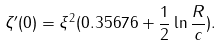Convert formula to latex. <formula><loc_0><loc_0><loc_500><loc_500>\zeta ^ { \prime } ( 0 ) = \xi ^ { 2 } ( 0 . 3 5 6 7 6 + \frac { 1 } { 2 } \ln \frac { R } { c } ) .</formula> 